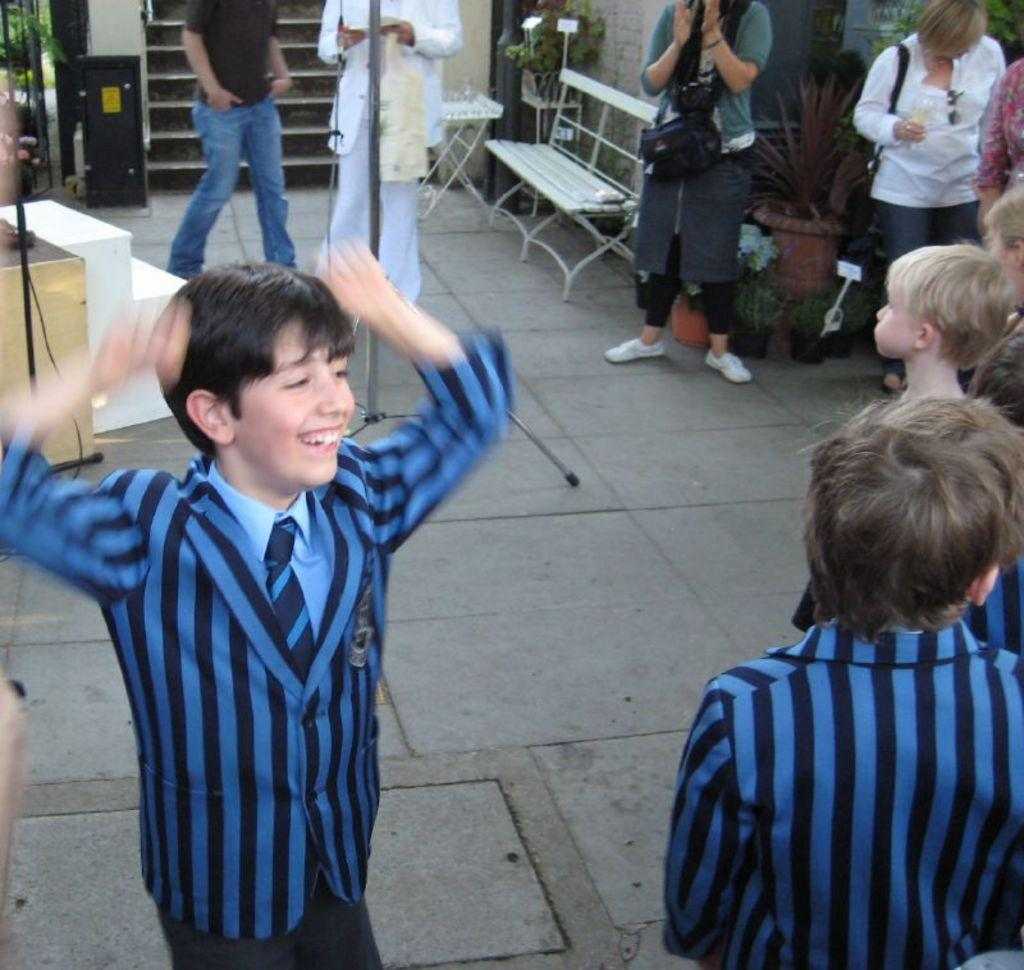What is the main subject of the image? The main subject of the image is a crowd. Where is the crowd located in the image? The crowd is standing on the floor. Are there any objects or furniture in the image? Yes, there is a seating chair in one corner and a flower pot in another corner of the image. What is happening between the two boys in the image? One boy is laughing at another boy in the image. What type of growth can be seen on the edge of the seating chair in the image? There is no growth visible on the edge of the seating chair in the image. 